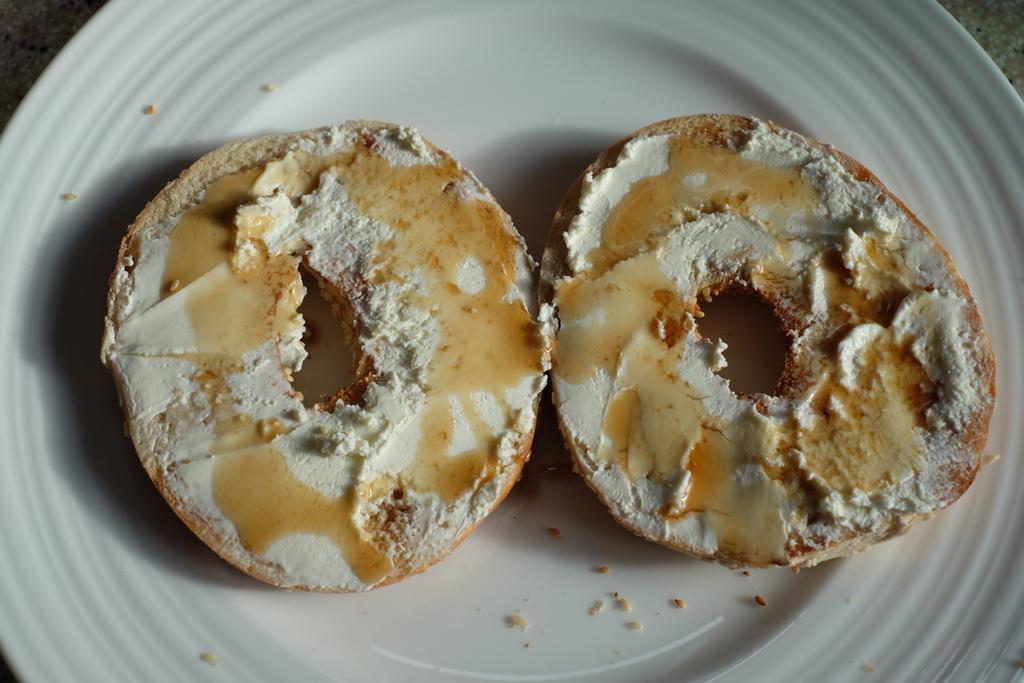Please provide a concise description of this image. In the picture I can see food items on a white color plate. 